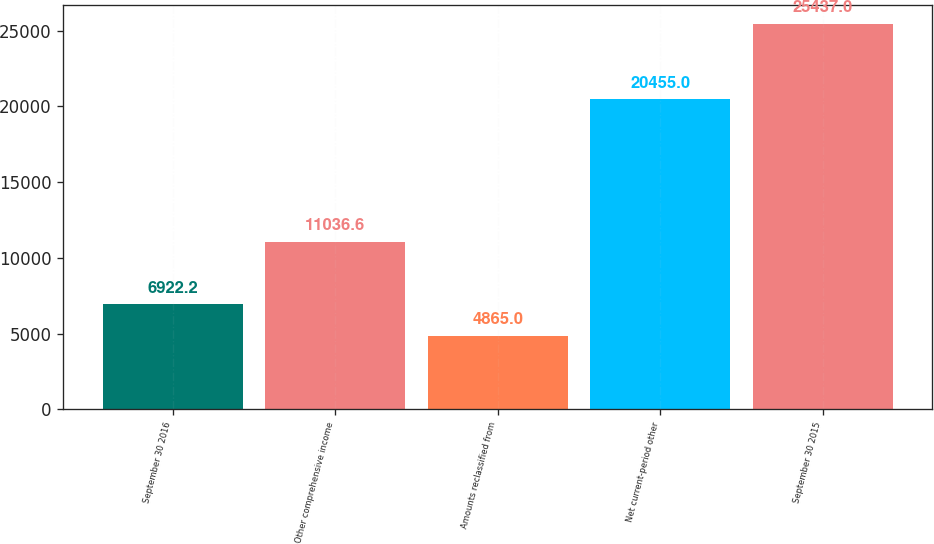Convert chart to OTSL. <chart><loc_0><loc_0><loc_500><loc_500><bar_chart><fcel>September 30 2016<fcel>Other comprehensive income<fcel>Amounts reclassified from<fcel>Net current-period other<fcel>September 30 2015<nl><fcel>6922.2<fcel>11036.6<fcel>4865<fcel>20455<fcel>25437<nl></chart> 